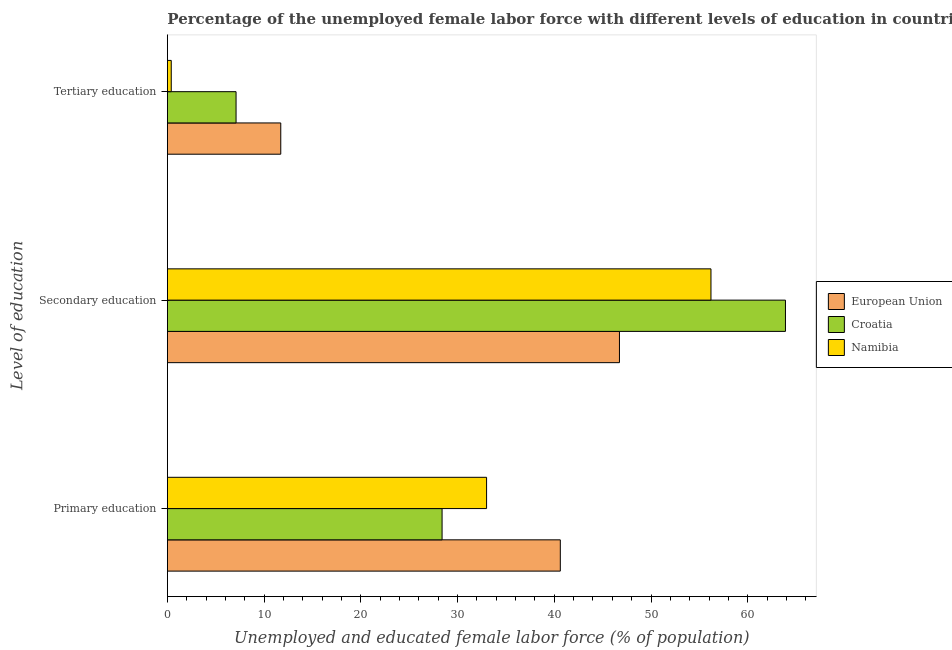How many bars are there on the 3rd tick from the top?
Offer a very short reply. 3. How many bars are there on the 1st tick from the bottom?
Ensure brevity in your answer.  3. What is the label of the 1st group of bars from the top?
Offer a very short reply. Tertiary education. What is the percentage of female labor force who received tertiary education in Croatia?
Your answer should be very brief. 7.1. Across all countries, what is the maximum percentage of female labor force who received secondary education?
Your response must be concise. 63.9. Across all countries, what is the minimum percentage of female labor force who received tertiary education?
Keep it short and to the point. 0.4. In which country was the percentage of female labor force who received tertiary education maximum?
Ensure brevity in your answer.  European Union. In which country was the percentage of female labor force who received secondary education minimum?
Provide a succinct answer. European Union. What is the total percentage of female labor force who received primary education in the graph?
Offer a terse response. 102.02. What is the difference between the percentage of female labor force who received secondary education in Croatia and that in Namibia?
Make the answer very short. 7.7. What is the difference between the percentage of female labor force who received primary education in Namibia and the percentage of female labor force who received tertiary education in European Union?
Make the answer very short. 21.28. What is the average percentage of female labor force who received primary education per country?
Offer a very short reply. 34.01. What is the difference between the percentage of female labor force who received tertiary education and percentage of female labor force who received secondary education in Croatia?
Provide a short and direct response. -56.8. What is the ratio of the percentage of female labor force who received primary education in Namibia to that in Croatia?
Provide a short and direct response. 1.16. What is the difference between the highest and the second highest percentage of female labor force who received tertiary education?
Keep it short and to the point. 4.62. What is the difference between the highest and the lowest percentage of female labor force who received secondary education?
Provide a succinct answer. 17.16. In how many countries, is the percentage of female labor force who received tertiary education greater than the average percentage of female labor force who received tertiary education taken over all countries?
Your answer should be compact. 2. Is the sum of the percentage of female labor force who received primary education in Namibia and Croatia greater than the maximum percentage of female labor force who received secondary education across all countries?
Your response must be concise. No. What does the 3rd bar from the top in Secondary education represents?
Your response must be concise. European Union. What does the 3rd bar from the bottom in Primary education represents?
Your response must be concise. Namibia. Is it the case that in every country, the sum of the percentage of female labor force who received primary education and percentage of female labor force who received secondary education is greater than the percentage of female labor force who received tertiary education?
Keep it short and to the point. Yes. How many bars are there?
Provide a succinct answer. 9. Are all the bars in the graph horizontal?
Keep it short and to the point. Yes. What is the difference between two consecutive major ticks on the X-axis?
Give a very brief answer. 10. Does the graph contain any zero values?
Provide a short and direct response. No. How many legend labels are there?
Offer a very short reply. 3. What is the title of the graph?
Make the answer very short. Percentage of the unemployed female labor force with different levels of education in countries. What is the label or title of the X-axis?
Offer a very short reply. Unemployed and educated female labor force (% of population). What is the label or title of the Y-axis?
Your answer should be very brief. Level of education. What is the Unemployed and educated female labor force (% of population) in European Union in Primary education?
Make the answer very short. 40.62. What is the Unemployed and educated female labor force (% of population) of Croatia in Primary education?
Provide a short and direct response. 28.4. What is the Unemployed and educated female labor force (% of population) in European Union in Secondary education?
Offer a very short reply. 46.74. What is the Unemployed and educated female labor force (% of population) in Croatia in Secondary education?
Provide a short and direct response. 63.9. What is the Unemployed and educated female labor force (% of population) in Namibia in Secondary education?
Offer a terse response. 56.2. What is the Unemployed and educated female labor force (% of population) of European Union in Tertiary education?
Make the answer very short. 11.72. What is the Unemployed and educated female labor force (% of population) of Croatia in Tertiary education?
Give a very brief answer. 7.1. What is the Unemployed and educated female labor force (% of population) of Namibia in Tertiary education?
Offer a terse response. 0.4. Across all Level of education, what is the maximum Unemployed and educated female labor force (% of population) in European Union?
Your response must be concise. 46.74. Across all Level of education, what is the maximum Unemployed and educated female labor force (% of population) of Croatia?
Make the answer very short. 63.9. Across all Level of education, what is the maximum Unemployed and educated female labor force (% of population) of Namibia?
Your response must be concise. 56.2. Across all Level of education, what is the minimum Unemployed and educated female labor force (% of population) in European Union?
Make the answer very short. 11.72. Across all Level of education, what is the minimum Unemployed and educated female labor force (% of population) in Croatia?
Keep it short and to the point. 7.1. Across all Level of education, what is the minimum Unemployed and educated female labor force (% of population) of Namibia?
Offer a terse response. 0.4. What is the total Unemployed and educated female labor force (% of population) of European Union in the graph?
Offer a terse response. 99.08. What is the total Unemployed and educated female labor force (% of population) of Croatia in the graph?
Provide a succinct answer. 99.4. What is the total Unemployed and educated female labor force (% of population) in Namibia in the graph?
Make the answer very short. 89.6. What is the difference between the Unemployed and educated female labor force (% of population) in European Union in Primary education and that in Secondary education?
Provide a succinct answer. -6.12. What is the difference between the Unemployed and educated female labor force (% of population) of Croatia in Primary education and that in Secondary education?
Ensure brevity in your answer.  -35.5. What is the difference between the Unemployed and educated female labor force (% of population) in Namibia in Primary education and that in Secondary education?
Provide a succinct answer. -23.2. What is the difference between the Unemployed and educated female labor force (% of population) of European Union in Primary education and that in Tertiary education?
Your response must be concise. 28.9. What is the difference between the Unemployed and educated female labor force (% of population) of Croatia in Primary education and that in Tertiary education?
Your answer should be very brief. 21.3. What is the difference between the Unemployed and educated female labor force (% of population) of Namibia in Primary education and that in Tertiary education?
Make the answer very short. 32.6. What is the difference between the Unemployed and educated female labor force (% of population) of European Union in Secondary education and that in Tertiary education?
Ensure brevity in your answer.  35.02. What is the difference between the Unemployed and educated female labor force (% of population) of Croatia in Secondary education and that in Tertiary education?
Offer a very short reply. 56.8. What is the difference between the Unemployed and educated female labor force (% of population) of Namibia in Secondary education and that in Tertiary education?
Provide a succinct answer. 55.8. What is the difference between the Unemployed and educated female labor force (% of population) of European Union in Primary education and the Unemployed and educated female labor force (% of population) of Croatia in Secondary education?
Keep it short and to the point. -23.28. What is the difference between the Unemployed and educated female labor force (% of population) of European Union in Primary education and the Unemployed and educated female labor force (% of population) of Namibia in Secondary education?
Ensure brevity in your answer.  -15.58. What is the difference between the Unemployed and educated female labor force (% of population) of Croatia in Primary education and the Unemployed and educated female labor force (% of population) of Namibia in Secondary education?
Offer a very short reply. -27.8. What is the difference between the Unemployed and educated female labor force (% of population) of European Union in Primary education and the Unemployed and educated female labor force (% of population) of Croatia in Tertiary education?
Give a very brief answer. 33.52. What is the difference between the Unemployed and educated female labor force (% of population) of European Union in Primary education and the Unemployed and educated female labor force (% of population) of Namibia in Tertiary education?
Offer a very short reply. 40.22. What is the difference between the Unemployed and educated female labor force (% of population) in European Union in Secondary education and the Unemployed and educated female labor force (% of population) in Croatia in Tertiary education?
Your response must be concise. 39.64. What is the difference between the Unemployed and educated female labor force (% of population) of European Union in Secondary education and the Unemployed and educated female labor force (% of population) of Namibia in Tertiary education?
Your answer should be very brief. 46.34. What is the difference between the Unemployed and educated female labor force (% of population) of Croatia in Secondary education and the Unemployed and educated female labor force (% of population) of Namibia in Tertiary education?
Your answer should be compact. 63.5. What is the average Unemployed and educated female labor force (% of population) of European Union per Level of education?
Make the answer very short. 33.03. What is the average Unemployed and educated female labor force (% of population) of Croatia per Level of education?
Make the answer very short. 33.13. What is the average Unemployed and educated female labor force (% of population) of Namibia per Level of education?
Your answer should be compact. 29.87. What is the difference between the Unemployed and educated female labor force (% of population) of European Union and Unemployed and educated female labor force (% of population) of Croatia in Primary education?
Provide a succinct answer. 12.22. What is the difference between the Unemployed and educated female labor force (% of population) in European Union and Unemployed and educated female labor force (% of population) in Namibia in Primary education?
Offer a terse response. 7.62. What is the difference between the Unemployed and educated female labor force (% of population) in European Union and Unemployed and educated female labor force (% of population) in Croatia in Secondary education?
Offer a very short reply. -17.16. What is the difference between the Unemployed and educated female labor force (% of population) in European Union and Unemployed and educated female labor force (% of population) in Namibia in Secondary education?
Make the answer very short. -9.46. What is the difference between the Unemployed and educated female labor force (% of population) in Croatia and Unemployed and educated female labor force (% of population) in Namibia in Secondary education?
Keep it short and to the point. 7.7. What is the difference between the Unemployed and educated female labor force (% of population) in European Union and Unemployed and educated female labor force (% of population) in Croatia in Tertiary education?
Provide a short and direct response. 4.62. What is the difference between the Unemployed and educated female labor force (% of population) of European Union and Unemployed and educated female labor force (% of population) of Namibia in Tertiary education?
Provide a short and direct response. 11.32. What is the ratio of the Unemployed and educated female labor force (% of population) of European Union in Primary education to that in Secondary education?
Your answer should be very brief. 0.87. What is the ratio of the Unemployed and educated female labor force (% of population) in Croatia in Primary education to that in Secondary education?
Your response must be concise. 0.44. What is the ratio of the Unemployed and educated female labor force (% of population) in Namibia in Primary education to that in Secondary education?
Keep it short and to the point. 0.59. What is the ratio of the Unemployed and educated female labor force (% of population) in European Union in Primary education to that in Tertiary education?
Offer a very short reply. 3.47. What is the ratio of the Unemployed and educated female labor force (% of population) in Croatia in Primary education to that in Tertiary education?
Provide a succinct answer. 4. What is the ratio of the Unemployed and educated female labor force (% of population) of Namibia in Primary education to that in Tertiary education?
Offer a terse response. 82.5. What is the ratio of the Unemployed and educated female labor force (% of population) of European Union in Secondary education to that in Tertiary education?
Your answer should be compact. 3.99. What is the ratio of the Unemployed and educated female labor force (% of population) of Croatia in Secondary education to that in Tertiary education?
Provide a short and direct response. 9. What is the ratio of the Unemployed and educated female labor force (% of population) of Namibia in Secondary education to that in Tertiary education?
Provide a succinct answer. 140.5. What is the difference between the highest and the second highest Unemployed and educated female labor force (% of population) of European Union?
Offer a very short reply. 6.12. What is the difference between the highest and the second highest Unemployed and educated female labor force (% of population) in Croatia?
Provide a succinct answer. 35.5. What is the difference between the highest and the second highest Unemployed and educated female labor force (% of population) in Namibia?
Provide a succinct answer. 23.2. What is the difference between the highest and the lowest Unemployed and educated female labor force (% of population) of European Union?
Keep it short and to the point. 35.02. What is the difference between the highest and the lowest Unemployed and educated female labor force (% of population) in Croatia?
Your answer should be very brief. 56.8. What is the difference between the highest and the lowest Unemployed and educated female labor force (% of population) of Namibia?
Your response must be concise. 55.8. 